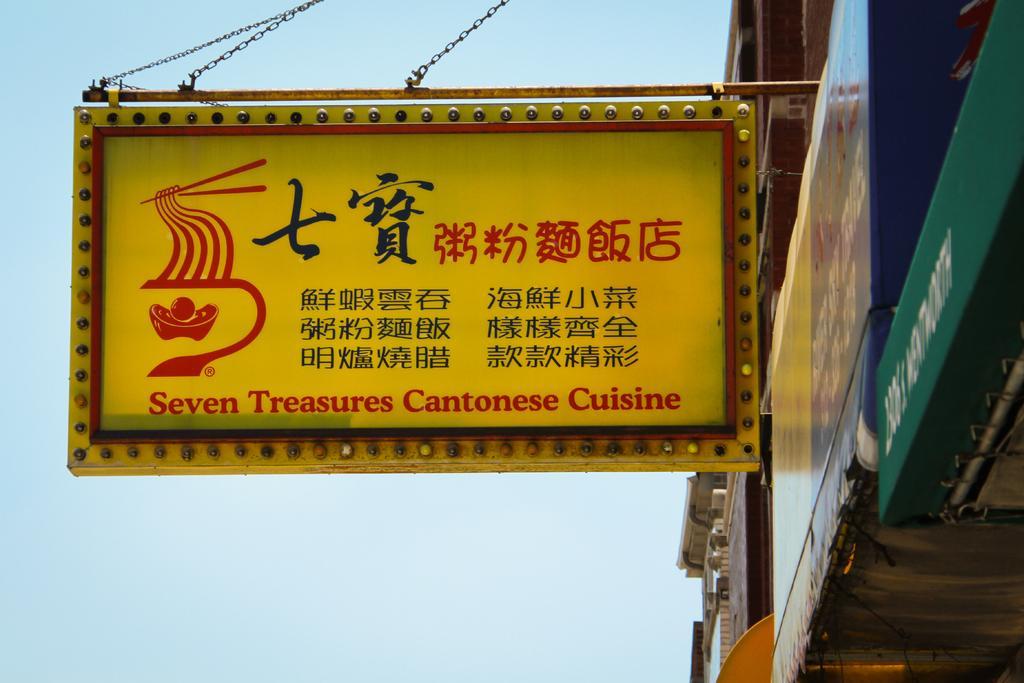Can you describe this image briefly? In this picture, on the right side, we can see some buildings, boards. In the middle of the image, we can also see a hoarding. In the background, we can also see a sky. 